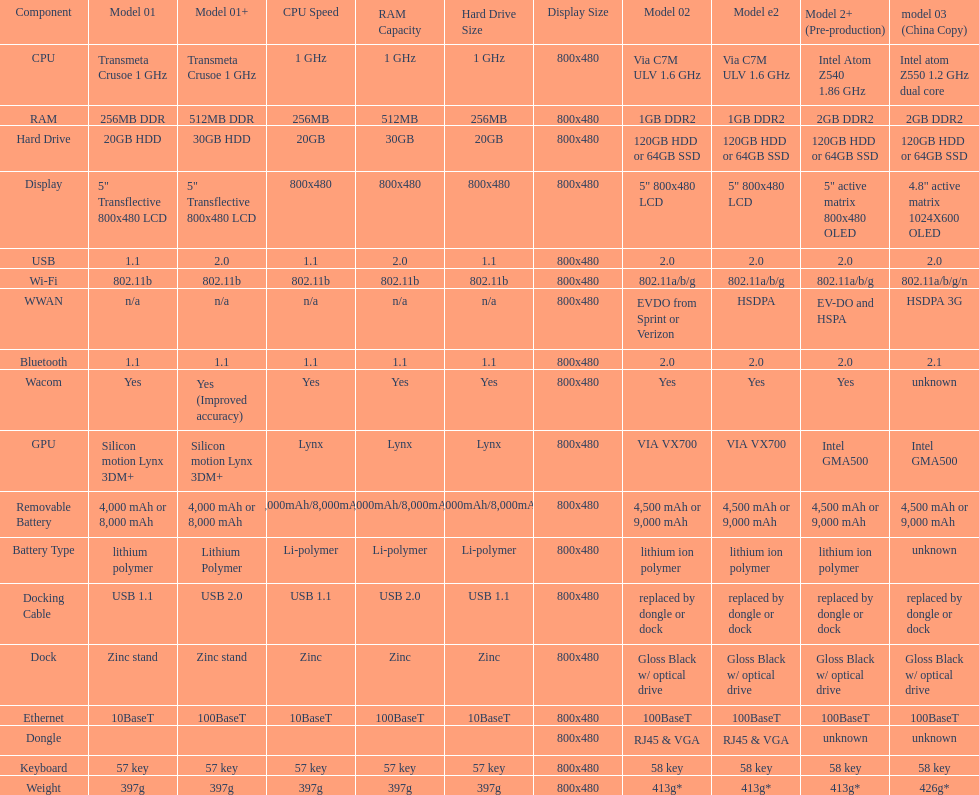0 compatibility? 5. 